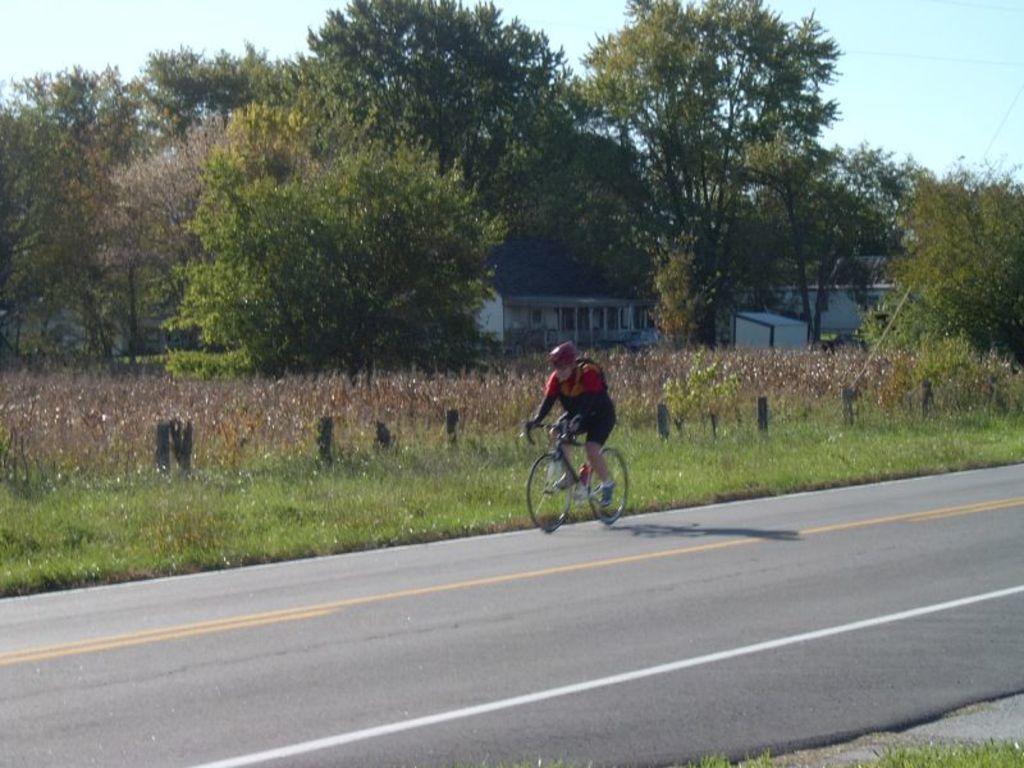Could you give a brief overview of what you see in this image? There is a person riding bicycle on the road. In the background there are trees,plants,grass,buildings,windows and sky. 